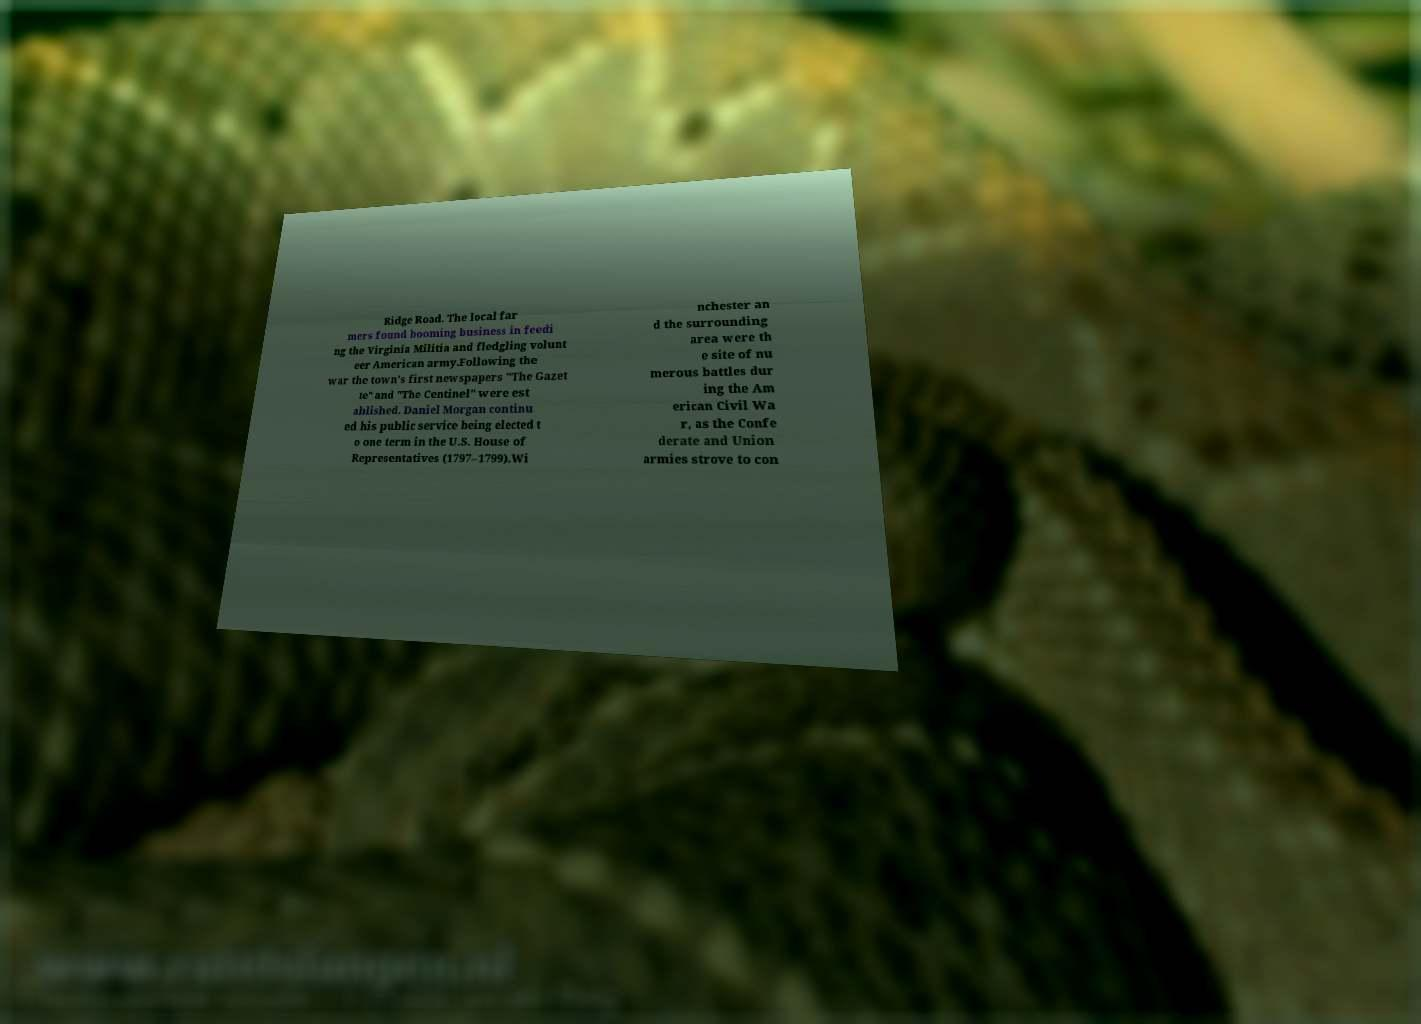There's text embedded in this image that I need extracted. Can you transcribe it verbatim? Ridge Road. The local far mers found booming business in feedi ng the Virginia Militia and fledgling volunt eer American army.Following the war the town's first newspapers "The Gazet te" and "The Centinel" were est ablished. Daniel Morgan continu ed his public service being elected t o one term in the U.S. House of Representatives (1797–1799).Wi nchester an d the surrounding area were th e site of nu merous battles dur ing the Am erican Civil Wa r, as the Confe derate and Union armies strove to con 